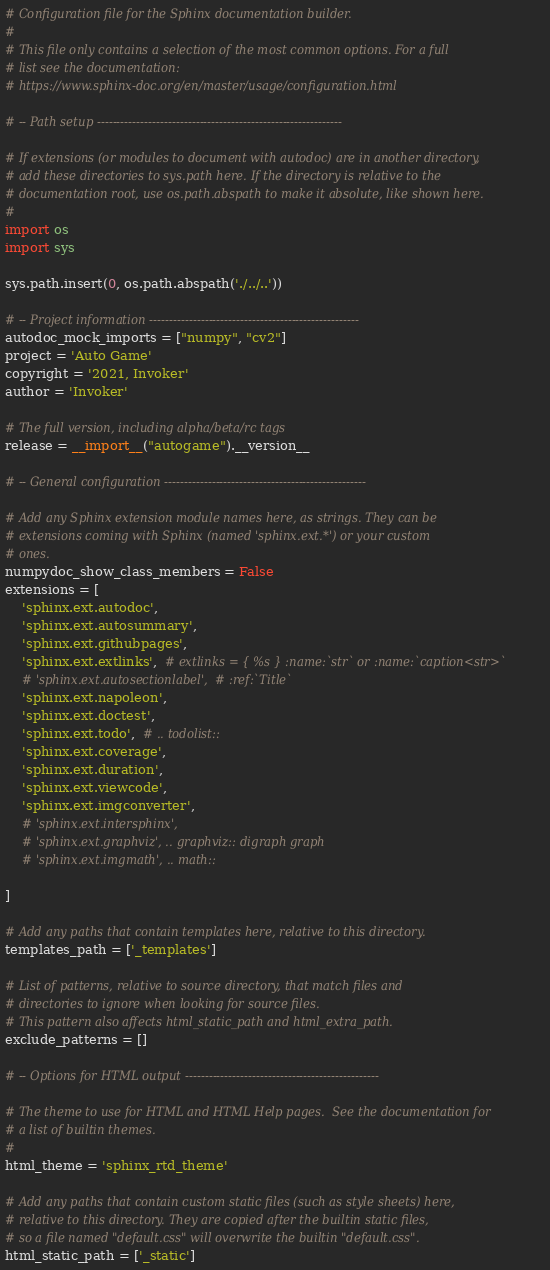<code> <loc_0><loc_0><loc_500><loc_500><_Python_># Configuration file for the Sphinx documentation builder.
#
# This file only contains a selection of the most common options. For a full
# list see the documentation:
# https://www.sphinx-doc.org/en/master/usage/configuration.html

# -- Path setup --------------------------------------------------------------

# If extensions (or modules to document with autodoc) are in another directory,
# add these directories to sys.path here. If the directory is relative to the
# documentation root, use os.path.abspath to make it absolute, like shown here.
#
import os
import sys

sys.path.insert(0, os.path.abspath('./../..'))

# -- Project information -----------------------------------------------------
autodoc_mock_imports = ["numpy", "cv2"]
project = 'Auto Game'
copyright = '2021, Invoker'
author = 'Invoker'

# The full version, including alpha/beta/rc tags
release = __import__("autogame").__version__

# -- General configuration ---------------------------------------------------

# Add any Sphinx extension module names here, as strings. They can be
# extensions coming with Sphinx (named 'sphinx.ext.*') or your custom
# ones.
numpydoc_show_class_members = False
extensions = [
    'sphinx.ext.autodoc',
    'sphinx.ext.autosummary',
    'sphinx.ext.githubpages',
    'sphinx.ext.extlinks',  # extlinks = { %s } :name:`str` or :name:`caption<str>`
    # 'sphinx.ext.autosectionlabel',  # :ref:`Title`
    'sphinx.ext.napoleon',
    'sphinx.ext.doctest',
    'sphinx.ext.todo',  # .. todolist::
    'sphinx.ext.coverage',
    'sphinx.ext.duration',
    'sphinx.ext.viewcode',
    'sphinx.ext.imgconverter',
    # 'sphinx.ext.intersphinx',
    # 'sphinx.ext.graphviz', .. graphviz:: digraph graph
    # 'sphinx.ext.imgmath', .. math::

]

# Add any paths that contain templates here, relative to this directory.
templates_path = ['_templates']

# List of patterns, relative to source directory, that match files and
# directories to ignore when looking for source files.
# This pattern also affects html_static_path and html_extra_path.
exclude_patterns = []

# -- Options for HTML output -------------------------------------------------

# The theme to use for HTML and HTML Help pages.  See the documentation for
# a list of builtin themes.
#
html_theme = 'sphinx_rtd_theme'

# Add any paths that contain custom static files (such as style sheets) here,
# relative to this directory. They are copied after the builtin static files,
# so a file named "default.css" will overwrite the builtin "default.css".
html_static_path = ['_static']
</code> 